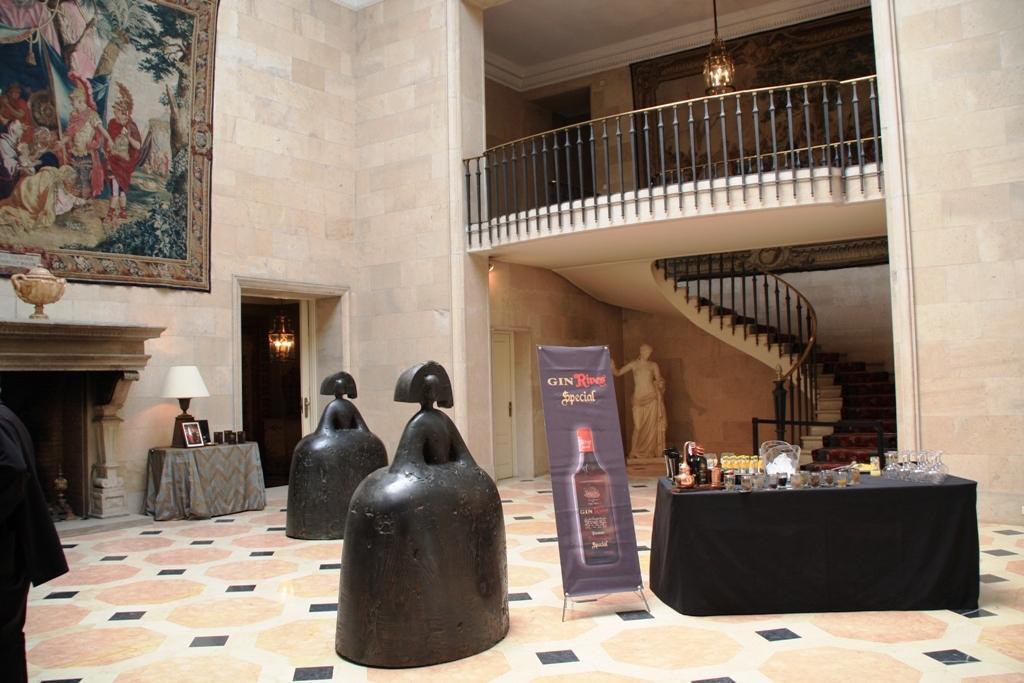In one or two sentences, can you explain what this image depicts? This is an inside view in this image in the center there is a railing and some stairs, and beside the stairs there is one statue and in the foreground there is one table. On the table there are some glasses and bottles, beside the table there is one board and also there are two objects. On the left side there is one table, on the table there are some photo frames and one lamp and at the top of the right corner there is one photo frame on the wall. And also on the left side there is one table, on the table there is one cup. At the bottom there is a floor, and at the top there is light. 